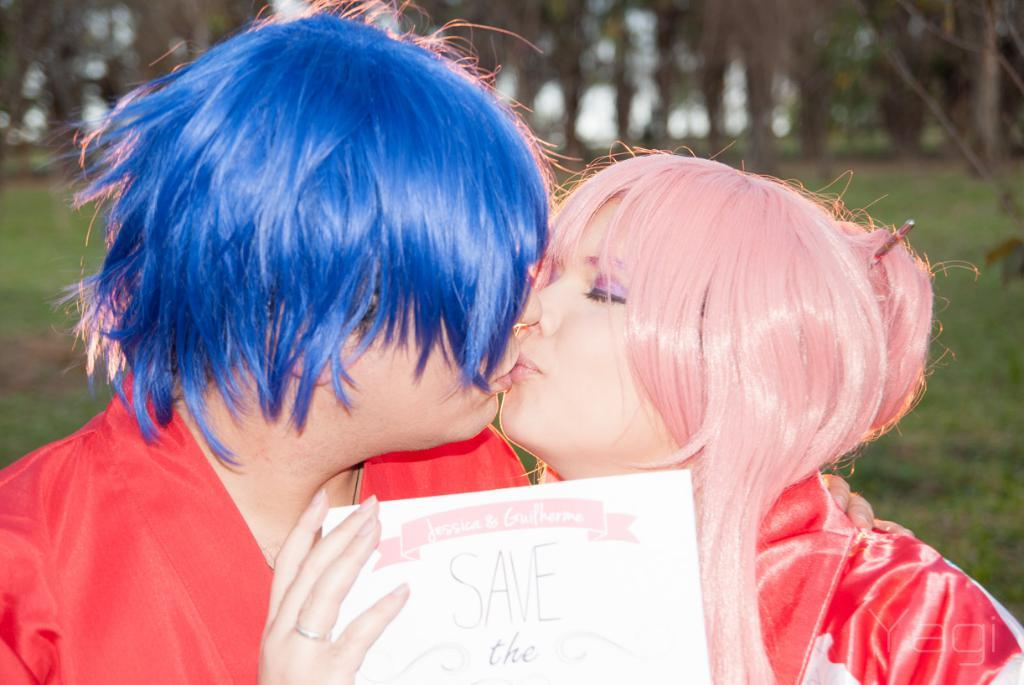How many people are in the image? There are two persons in the image. What are the persons holding in the image? The persons are holding a paper. What can be seen in the background of the image? There is grass and trees in the background of the image. What type of stem can be seen in the image? There is no stem present in the image. What are the persons reading in the image? The provided facts do not mention anything about reading, so we cannot determine if they are reading anything. 